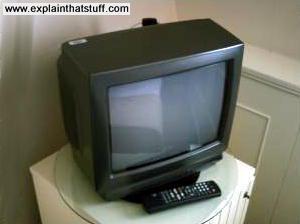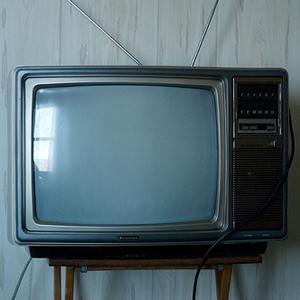The first image is the image on the left, the second image is the image on the right. Assess this claim about the two images: "At least one of the images shows a remote next to the TV.". Correct or not? Answer yes or no. Yes. 